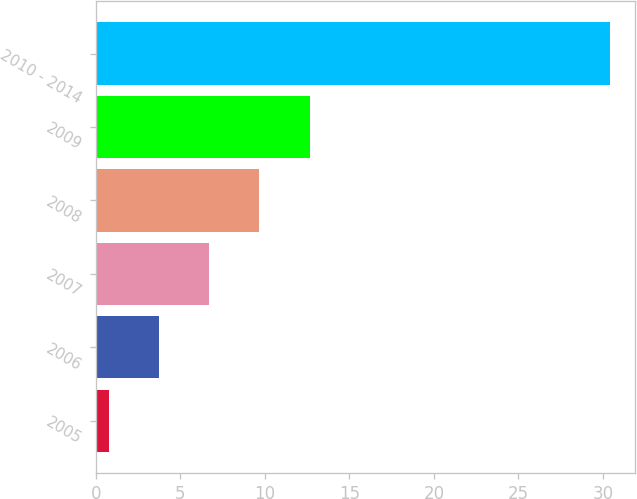<chart> <loc_0><loc_0><loc_500><loc_500><bar_chart><fcel>2005<fcel>2006<fcel>2007<fcel>2008<fcel>2009<fcel>2010 - 2014<nl><fcel>0.8<fcel>3.76<fcel>6.72<fcel>9.68<fcel>12.64<fcel>30.4<nl></chart> 